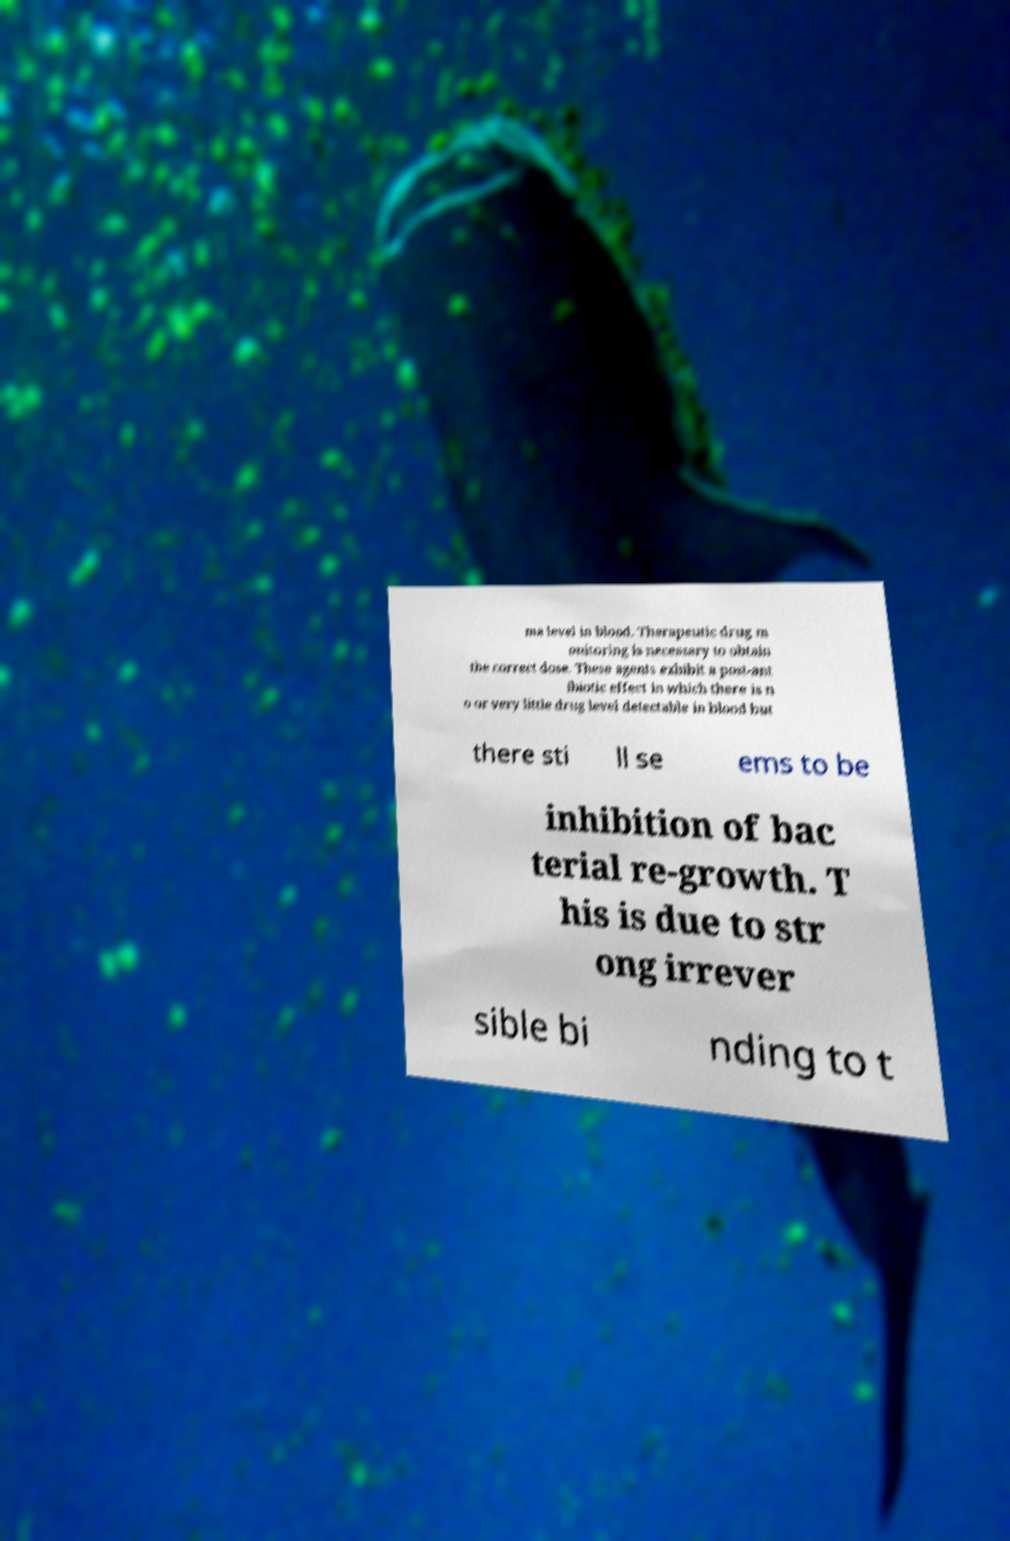Could you extract and type out the text from this image? ma level in blood. Therapeutic drug m onitoring is necessary to obtain the correct dose. These agents exhibit a post-ant ibiotic effect in which there is n o or very little drug level detectable in blood but there sti ll se ems to be inhibition of bac terial re-growth. T his is due to str ong irrever sible bi nding to t 